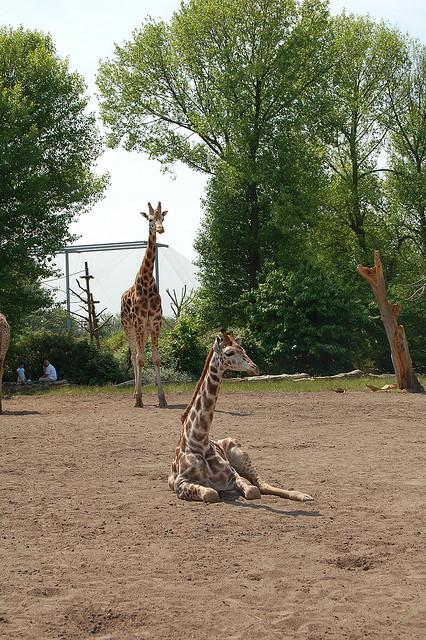What is the giraffe in the foreground doing? laying down 